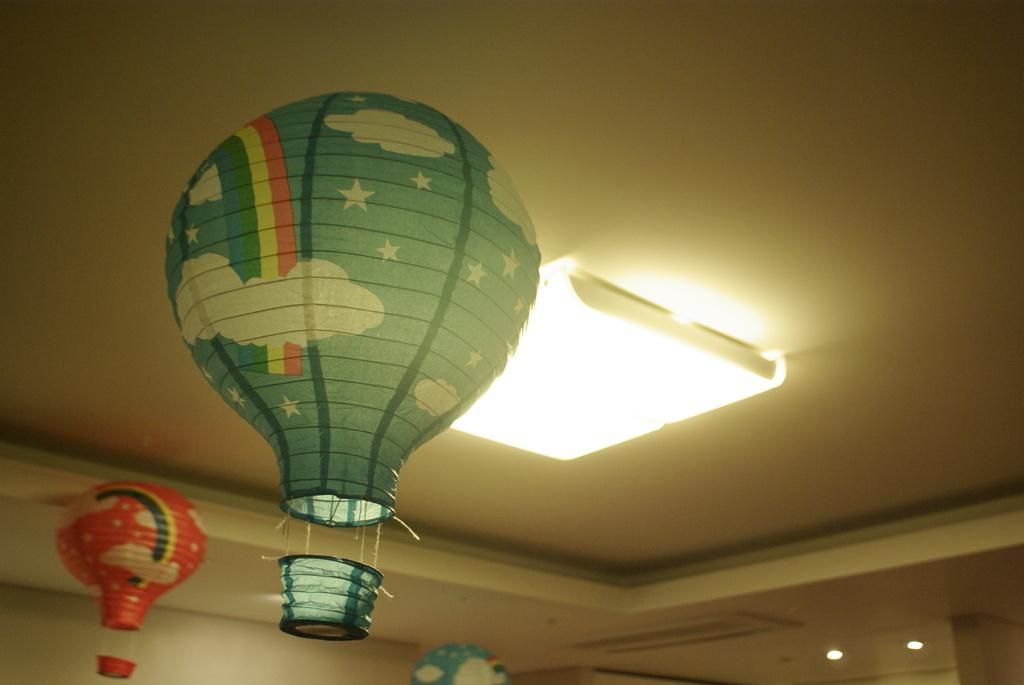What part of a house is shown in the image? The image shows the inner roof of a house. Are there any additional features on the roof? Yes, there are decorations attached to the roof. Can you describe the lighting in the image? A light is glowing in the image. What type of decision can be seen being made by the finger in the image? There is no finger present in the image, and therefore no decision-making can be observed. 